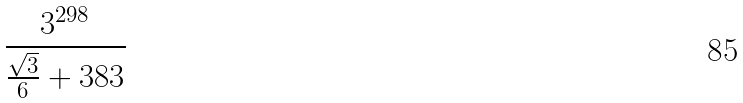<formula> <loc_0><loc_0><loc_500><loc_500>\frac { 3 ^ { 2 9 8 } } { \frac { \sqrt { 3 } } { 6 } + 3 8 3 }</formula> 